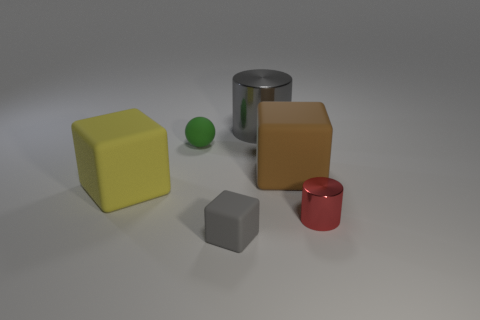Do the large brown matte object and the tiny green rubber thing have the same shape?
Your answer should be compact. No. What number of things are tiny objects that are to the left of the red object or tiny green balls?
Keep it short and to the point. 2. Are there the same number of brown rubber objects that are behind the small green rubber sphere and large brown rubber things that are in front of the red shiny object?
Keep it short and to the point. Yes. How many other objects are the same shape as the tiny metal object?
Offer a terse response. 1. Do the shiny cylinder that is in front of the tiny green object and the thing that is to the left of the small sphere have the same size?
Make the answer very short. No. How many spheres are gray objects or big gray things?
Provide a short and direct response. 0. What number of rubber things are tiny blocks or large yellow objects?
Provide a succinct answer. 2. What is the size of the yellow thing that is the same shape as the large brown rubber object?
Provide a succinct answer. Large. Is there anything else that is the same size as the brown matte thing?
Give a very brief answer. Yes. There is a rubber ball; is its size the same as the block that is right of the big cylinder?
Provide a succinct answer. No. 